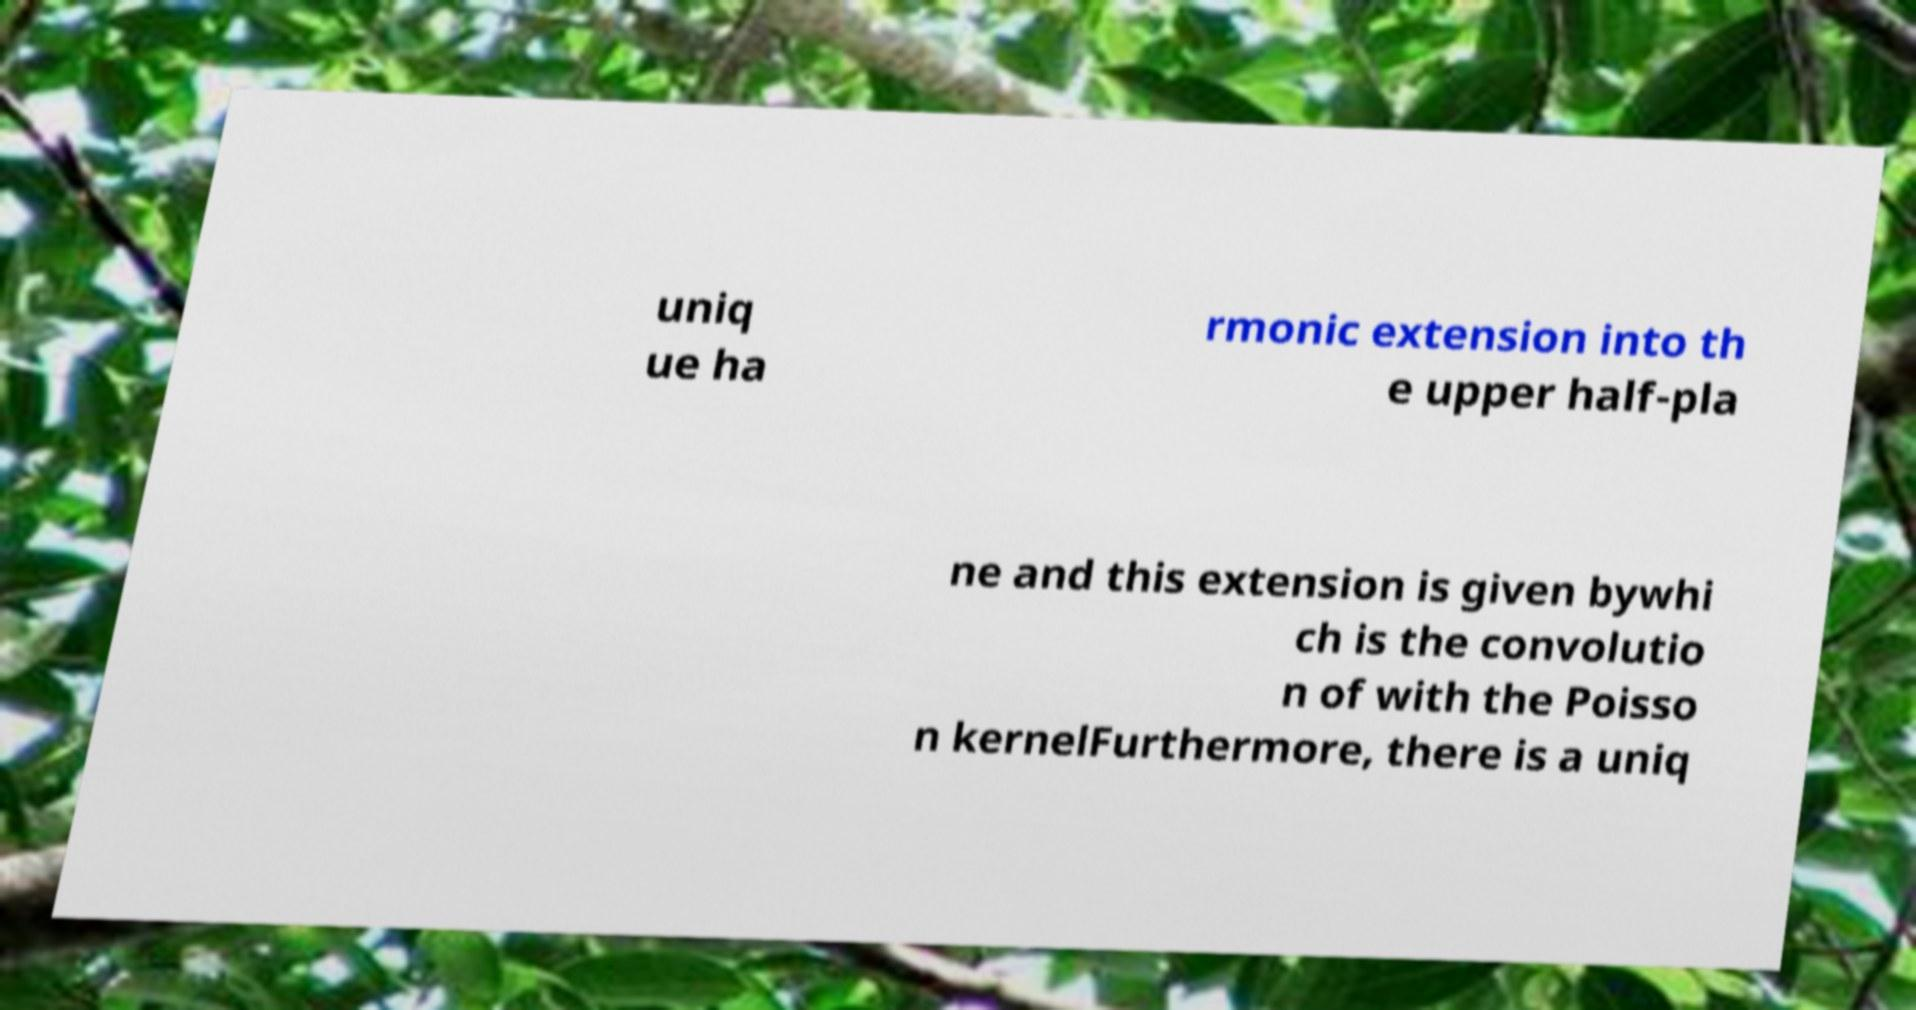Can you read and provide the text displayed in the image?This photo seems to have some interesting text. Can you extract and type it out for me? uniq ue ha rmonic extension into th e upper half-pla ne and this extension is given bywhi ch is the convolutio n of with the Poisso n kernelFurthermore, there is a uniq 